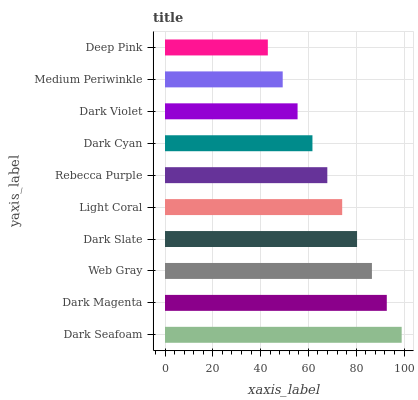Is Deep Pink the minimum?
Answer yes or no. Yes. Is Dark Seafoam the maximum?
Answer yes or no. Yes. Is Dark Magenta the minimum?
Answer yes or no. No. Is Dark Magenta the maximum?
Answer yes or no. No. Is Dark Seafoam greater than Dark Magenta?
Answer yes or no. Yes. Is Dark Magenta less than Dark Seafoam?
Answer yes or no. Yes. Is Dark Magenta greater than Dark Seafoam?
Answer yes or no. No. Is Dark Seafoam less than Dark Magenta?
Answer yes or no. No. Is Light Coral the high median?
Answer yes or no. Yes. Is Rebecca Purple the low median?
Answer yes or no. Yes. Is Medium Periwinkle the high median?
Answer yes or no. No. Is Dark Seafoam the low median?
Answer yes or no. No. 